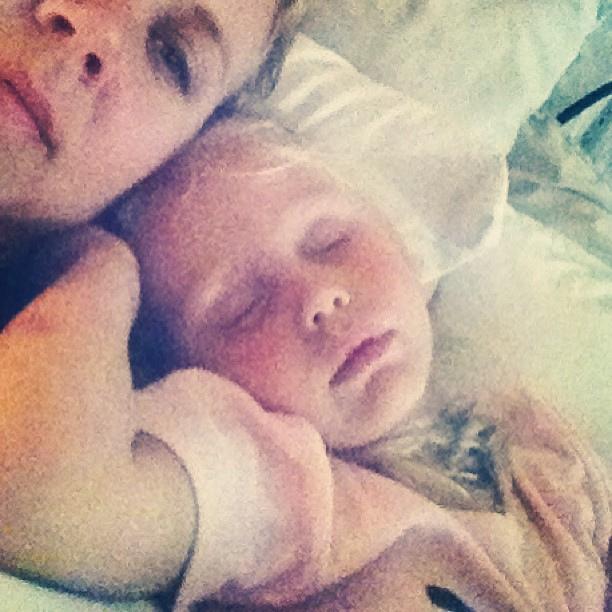What color hair does the child have?
Answer briefly. Blonde. How many people are in this picture?
Concise answer only. 2. Is the child sleeping?
Concise answer only. Yes. 